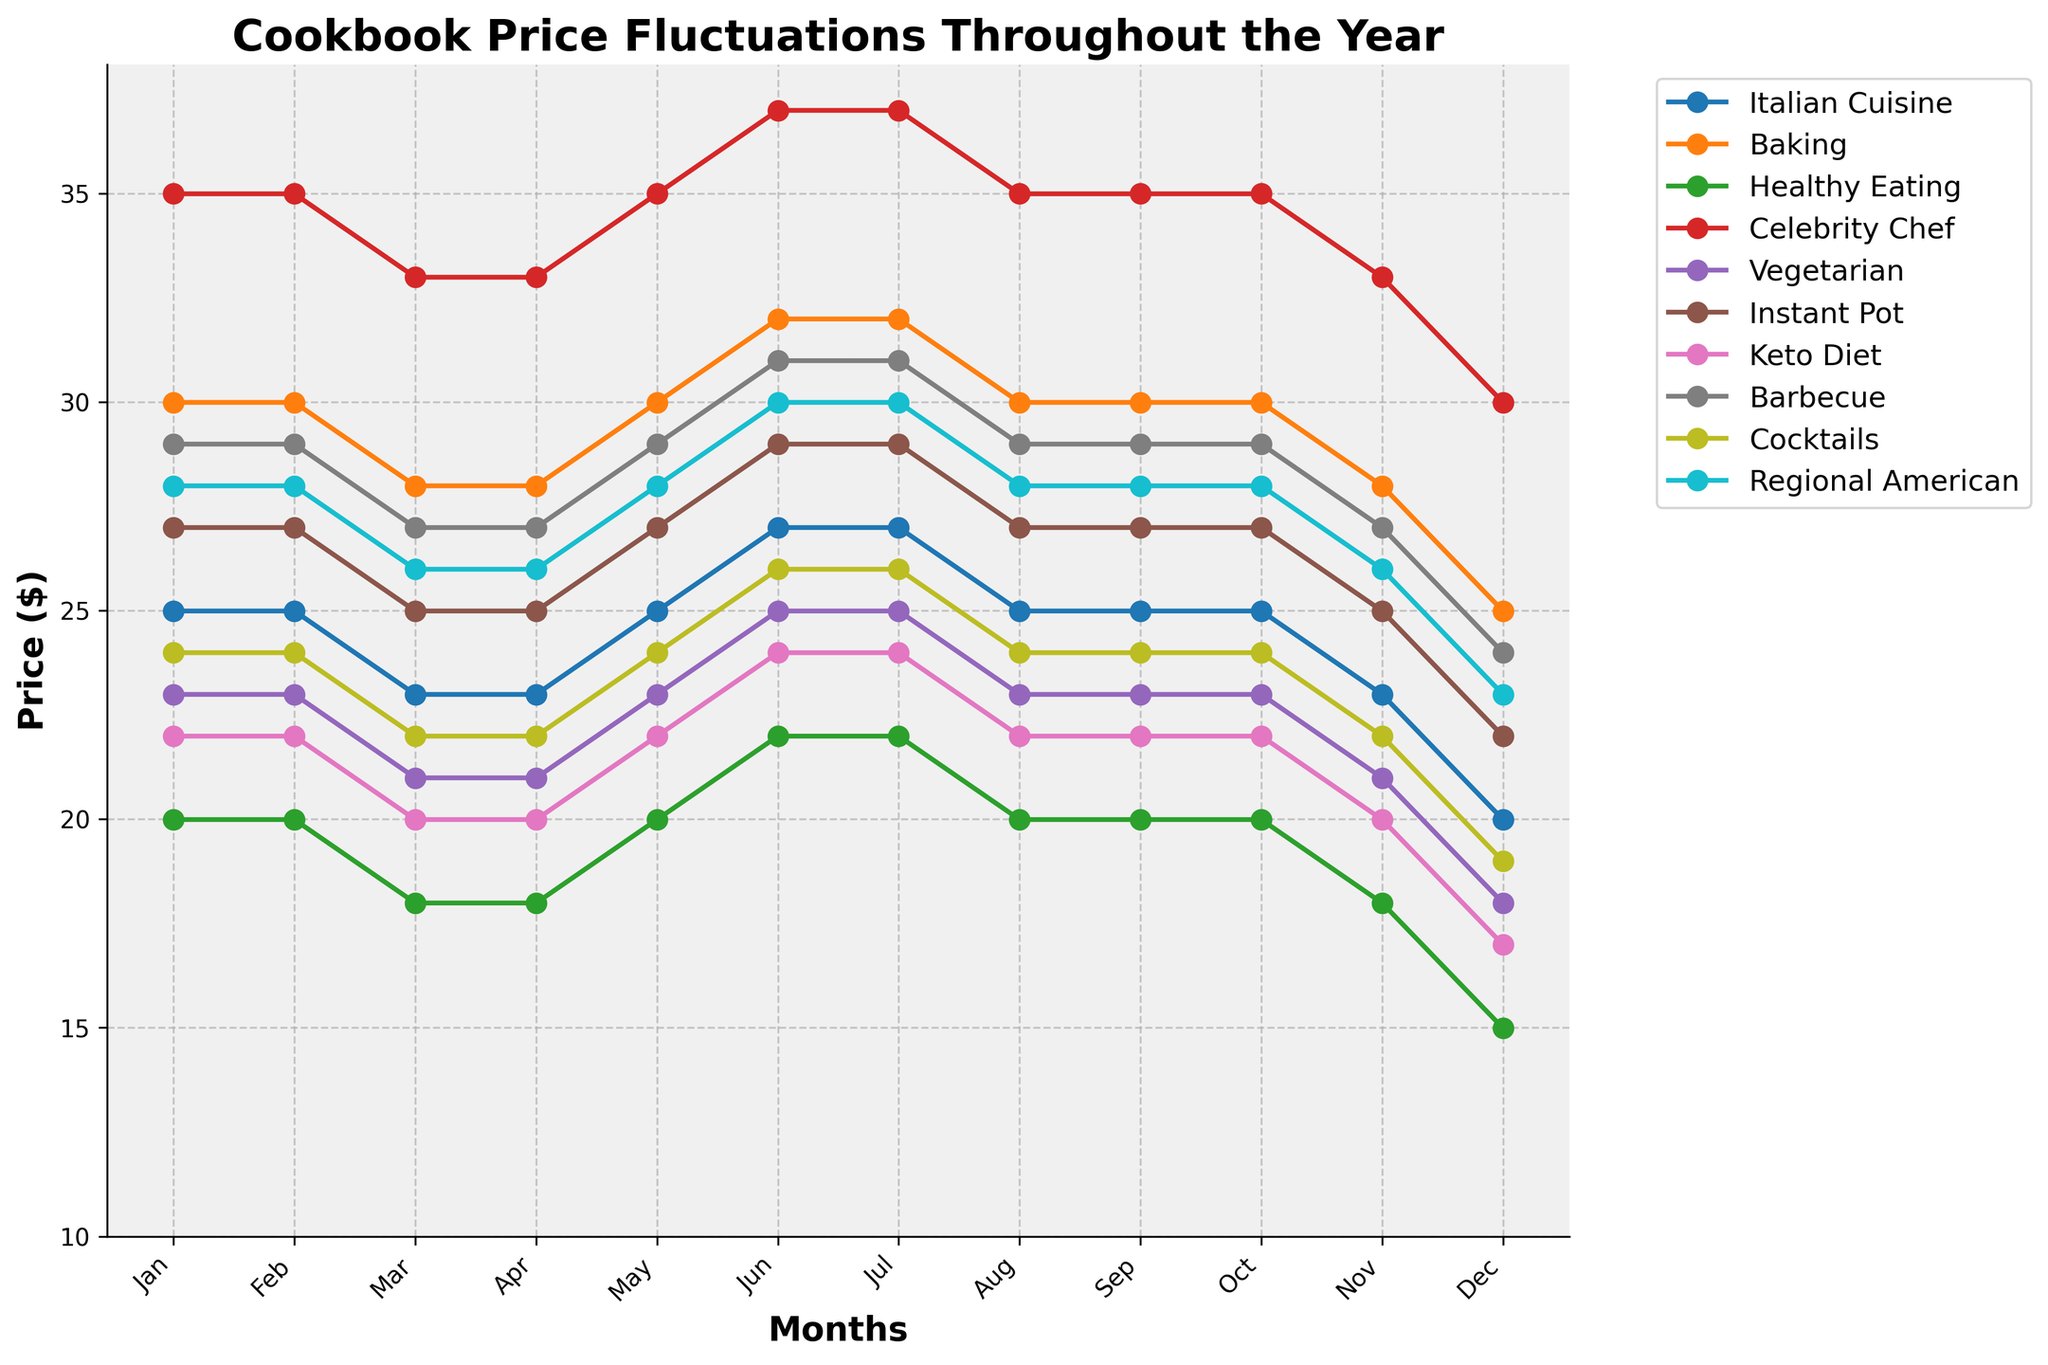Which category had the highest price in December? To determine which category had the highest price in December, look at the data points for December on the graph. The highest y-position (price) in December corresponds to the "Celebrity Chef" category.
Answer: Celebrity Chef Which months show a price drop for the "Baking" category? Examine the line for the "Baking" category and identify where the line slants downward. The months where the price drops are from January to March and from October to December.
Answer: January to March, October to December What’s the average price of "Healthy Eating" cookbooks in the second quarter (Apr-Jun)? Check the prices for "Healthy Eating" in April, May, and June: $17.99, $19.99, and $21.99 respectively. Sum these prices $(17.99 + 19.99 + 21.99 = 59.97)$ and divide by 3 $(59.97/3)$ to get the average price.
Answer: 19.99 By how much did the price of "Instant Pot" cookbooks decrease from June to December? The price in June for "Instant Pot" is $28.99. In December, it is $21.99. Subtract the two to find the decrease $(28.99 - 21.99)$.
Answer: 7.00 Which category had the most stable pricing throughout the year? Look for the category whose line is the most horizontal (least fluctuation). The "Italian Cuisine" category shows minimal changes with prices staying mostly at $24.99 and $22.99.
Answer: Italian Cuisine In which month did "Keto Diet" cookbooks start to recover their price after a drop? Identify the price drop and subsequent increase for "Keto Diet" books. The price drops up to March, and it starts to increase again in April.
Answer: April What is the price difference between the "Barbecue" and "Cocktails" categories in August? Find the August prices for "Barbecue" ($28.99) and "Cocktails" ($23.99), then subtract the "Cocktails" price from the "Barbecue" price $(28.99 - 23.99)$.
Answer: 5.00 Which cookbook category has seen its price drop the most in November from the beginning of the year? Compare January and November prices for all categories and find the biggest difference. "Healthy Eating" goes from $19.99 in January to $17.99 in November, showing a notable drop of $2.00.
Answer: Healthy Eating 